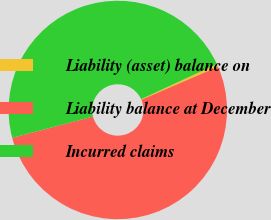Convert chart. <chart><loc_0><loc_0><loc_500><loc_500><pie_chart><fcel>Liability (asset) balance on<fcel>Liability balance at December<fcel>Incurred claims<nl><fcel>0.42%<fcel>52.37%<fcel>47.21%<nl></chart> 